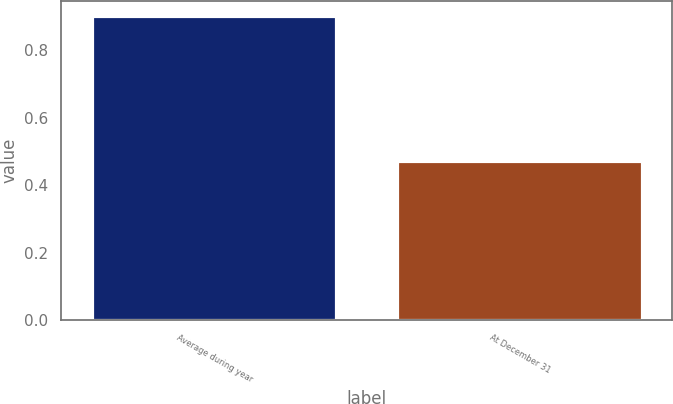<chart> <loc_0><loc_0><loc_500><loc_500><bar_chart><fcel>Average during year<fcel>At December 31<nl><fcel>0.9<fcel>0.47<nl></chart> 